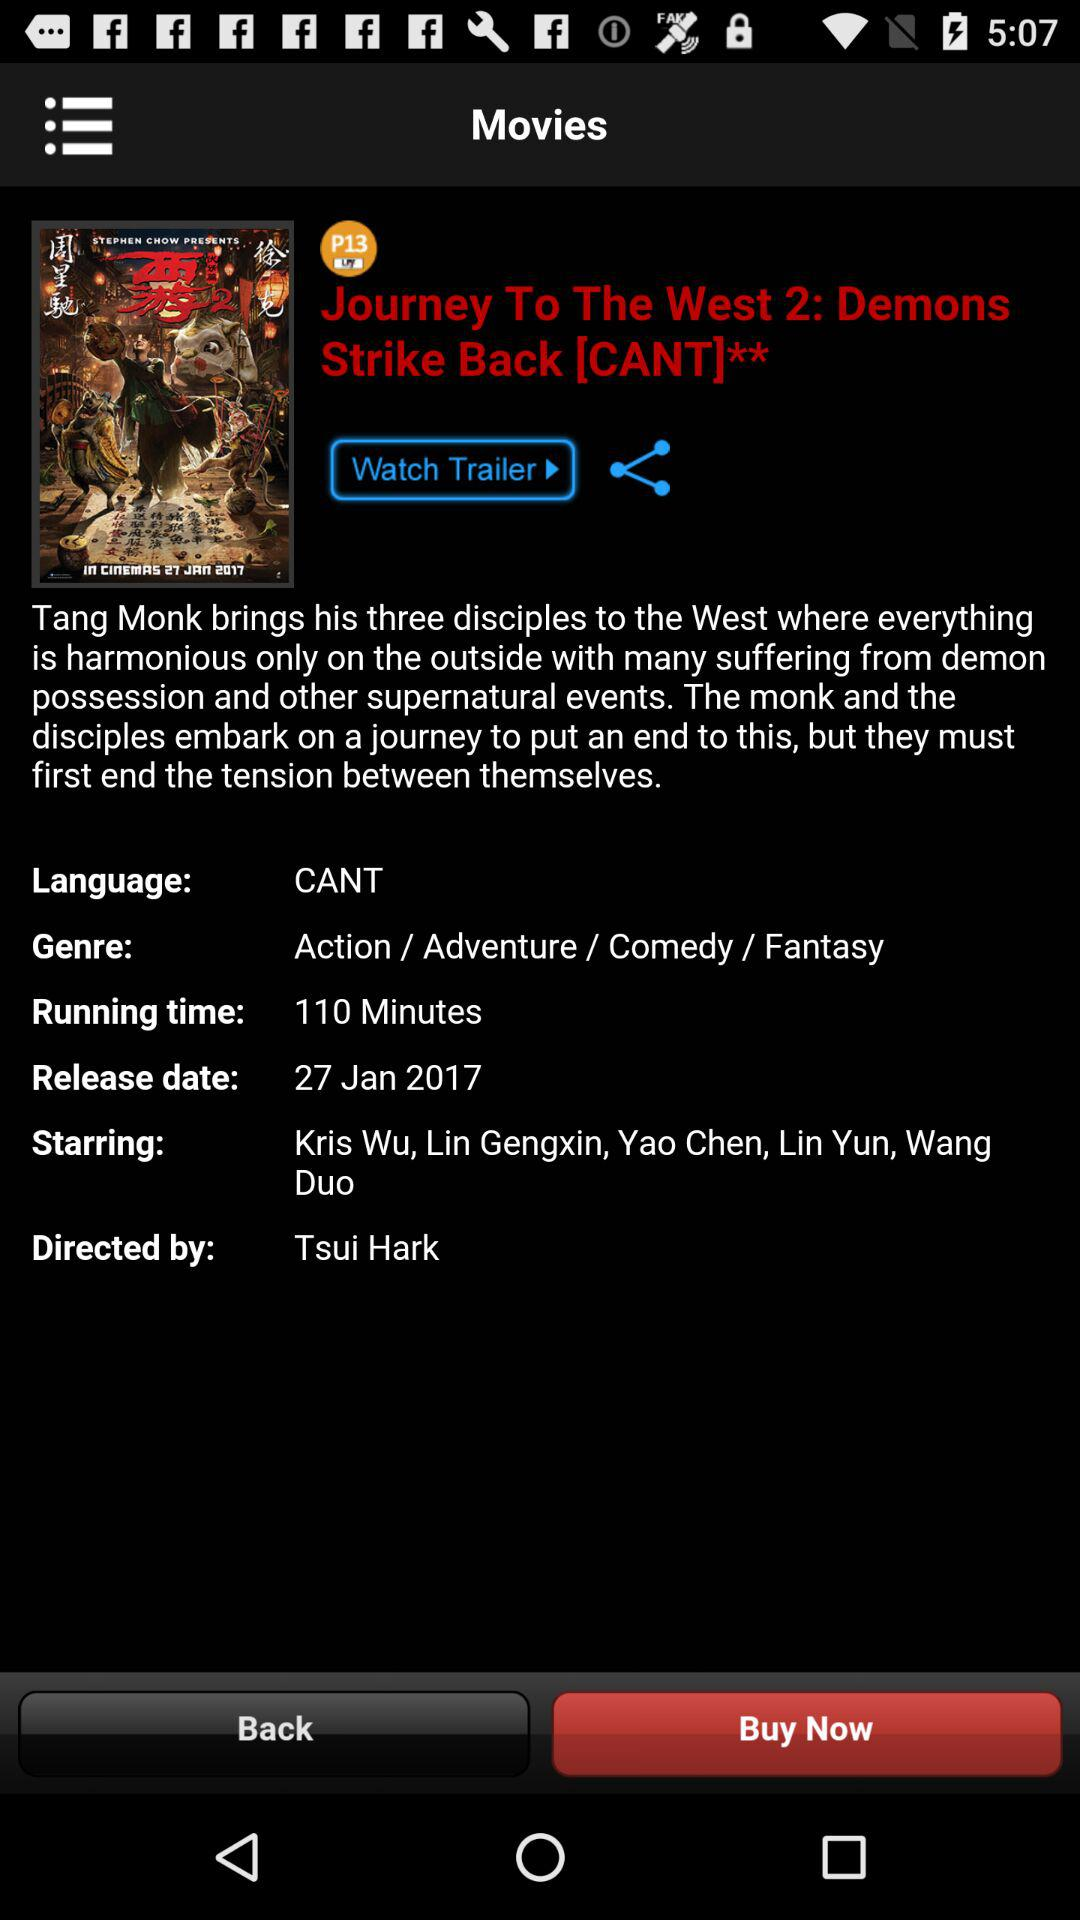What's the duration of the movie? The duration of the movie is 110 minutes. 